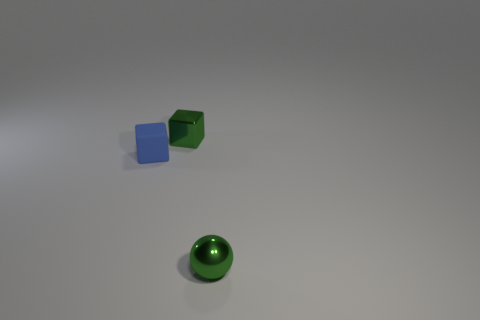Is the color of the metal thing that is in front of the small green metallic cube the same as the small metallic block?
Your response must be concise. Yes. The small thing that is both behind the green shiny ball and in front of the metal block is made of what material?
Give a very brief answer. Rubber. The shiny block has what size?
Provide a succinct answer. Small. Do the matte block and the small shiny object that is behind the green ball have the same color?
Make the answer very short. No. How many other objects are the same color as the small matte cube?
Keep it short and to the point. 0. There is a green metal thing that is to the left of the small green ball; does it have the same size as the metal object in front of the tiny rubber block?
Your answer should be very brief. Yes. There is a rubber block behind the small green metal sphere; what is its color?
Provide a succinct answer. Blue. Are there fewer small blue things that are right of the tiny green shiny cube than tiny green balls?
Your answer should be compact. Yes. Do the blue object and the green sphere have the same material?
Your answer should be very brief. No. The metal object that is the same shape as the tiny rubber thing is what size?
Provide a short and direct response. Small. 